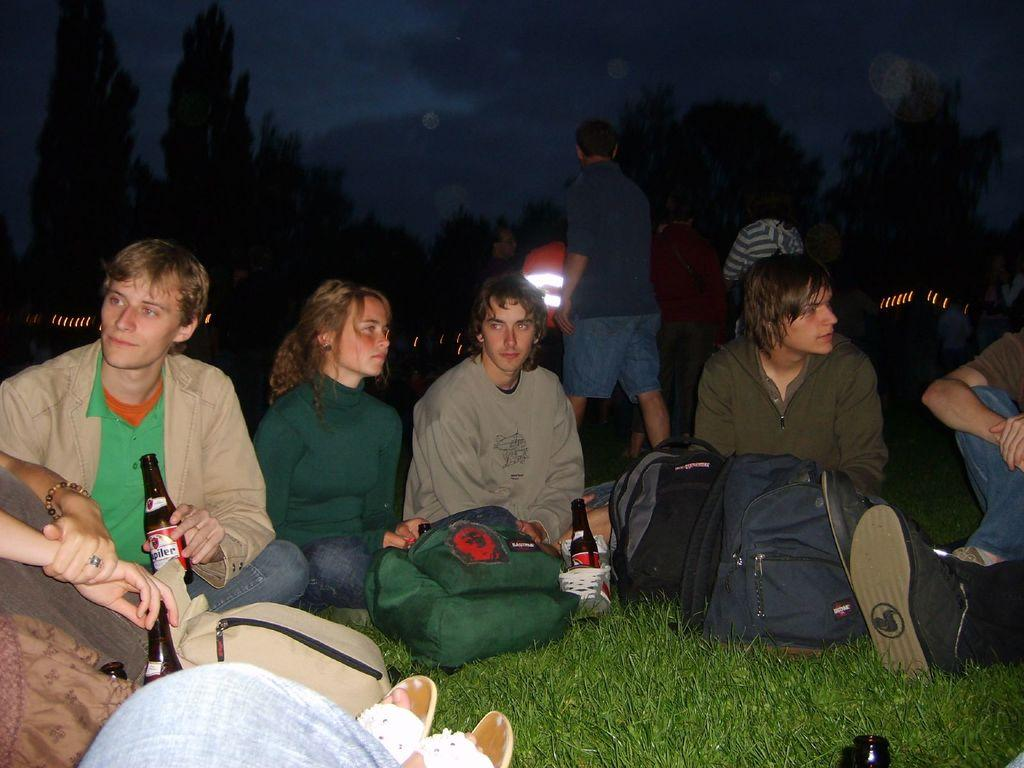How many people are in the image? There are multiple persons in the image. What are the persons carrying in front of them? There are bags in front of the persons. What else are some of the persons holding? Some of the persons are holding bottles. What can be seen at the top of the image? The sky and trees are visible at the top of the image. What type of notebook is the beginner using in the image? There is no notebook or beginner present in the image. 